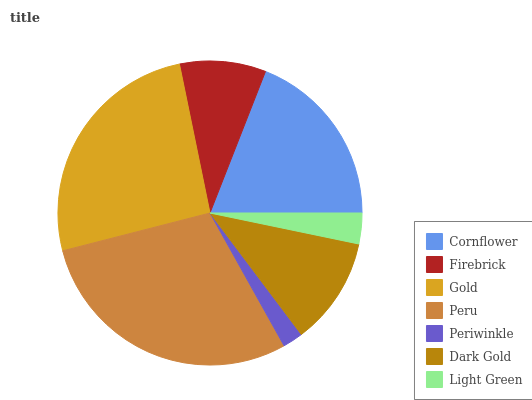Is Periwinkle the minimum?
Answer yes or no. Yes. Is Peru the maximum?
Answer yes or no. Yes. Is Firebrick the minimum?
Answer yes or no. No. Is Firebrick the maximum?
Answer yes or no. No. Is Cornflower greater than Firebrick?
Answer yes or no. Yes. Is Firebrick less than Cornflower?
Answer yes or no. Yes. Is Firebrick greater than Cornflower?
Answer yes or no. No. Is Cornflower less than Firebrick?
Answer yes or no. No. Is Dark Gold the high median?
Answer yes or no. Yes. Is Dark Gold the low median?
Answer yes or no. Yes. Is Peru the high median?
Answer yes or no. No. Is Firebrick the low median?
Answer yes or no. No. 